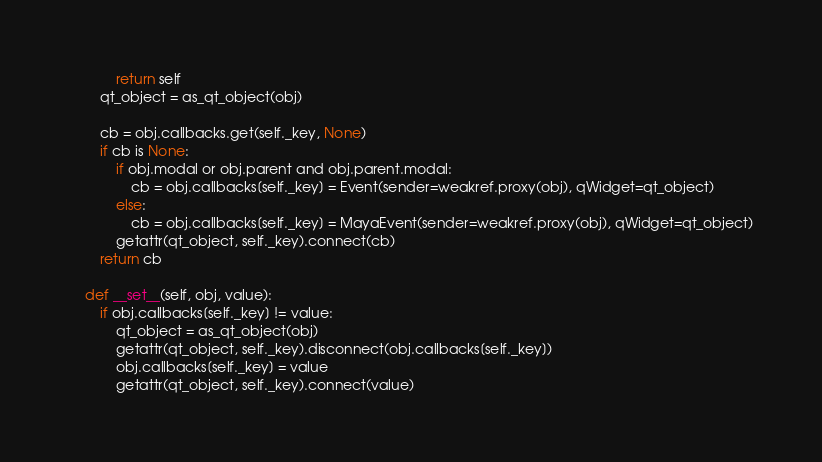Convert code to text. <code><loc_0><loc_0><loc_500><loc_500><_Python_>            return self
        qt_object = as_qt_object(obj)

        cb = obj.callbacks.get(self._key, None)
        if cb is None:
            if obj.modal or obj.parent and obj.parent.modal:
                cb = obj.callbacks[self._key] = Event(sender=weakref.proxy(obj), qWidget=qt_object)
            else:
                cb = obj.callbacks[self._key] = MayaEvent(sender=weakref.proxy(obj), qWidget=qt_object)
            getattr(qt_object, self._key).connect(cb)
        return cb

    def __set__(self, obj, value):
        if obj.callbacks[self._key] != value:
            qt_object = as_qt_object(obj)
            getattr(qt_object, self._key).disconnect(obj.callbacks[self._key])
            obj.callbacks[self._key] = value
            getattr(qt_object, self._key).connect(value)</code> 